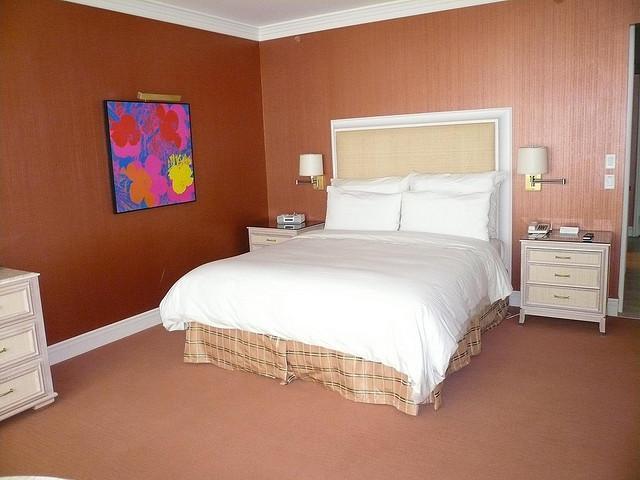How many men are drinking milk?
Give a very brief answer. 0. 